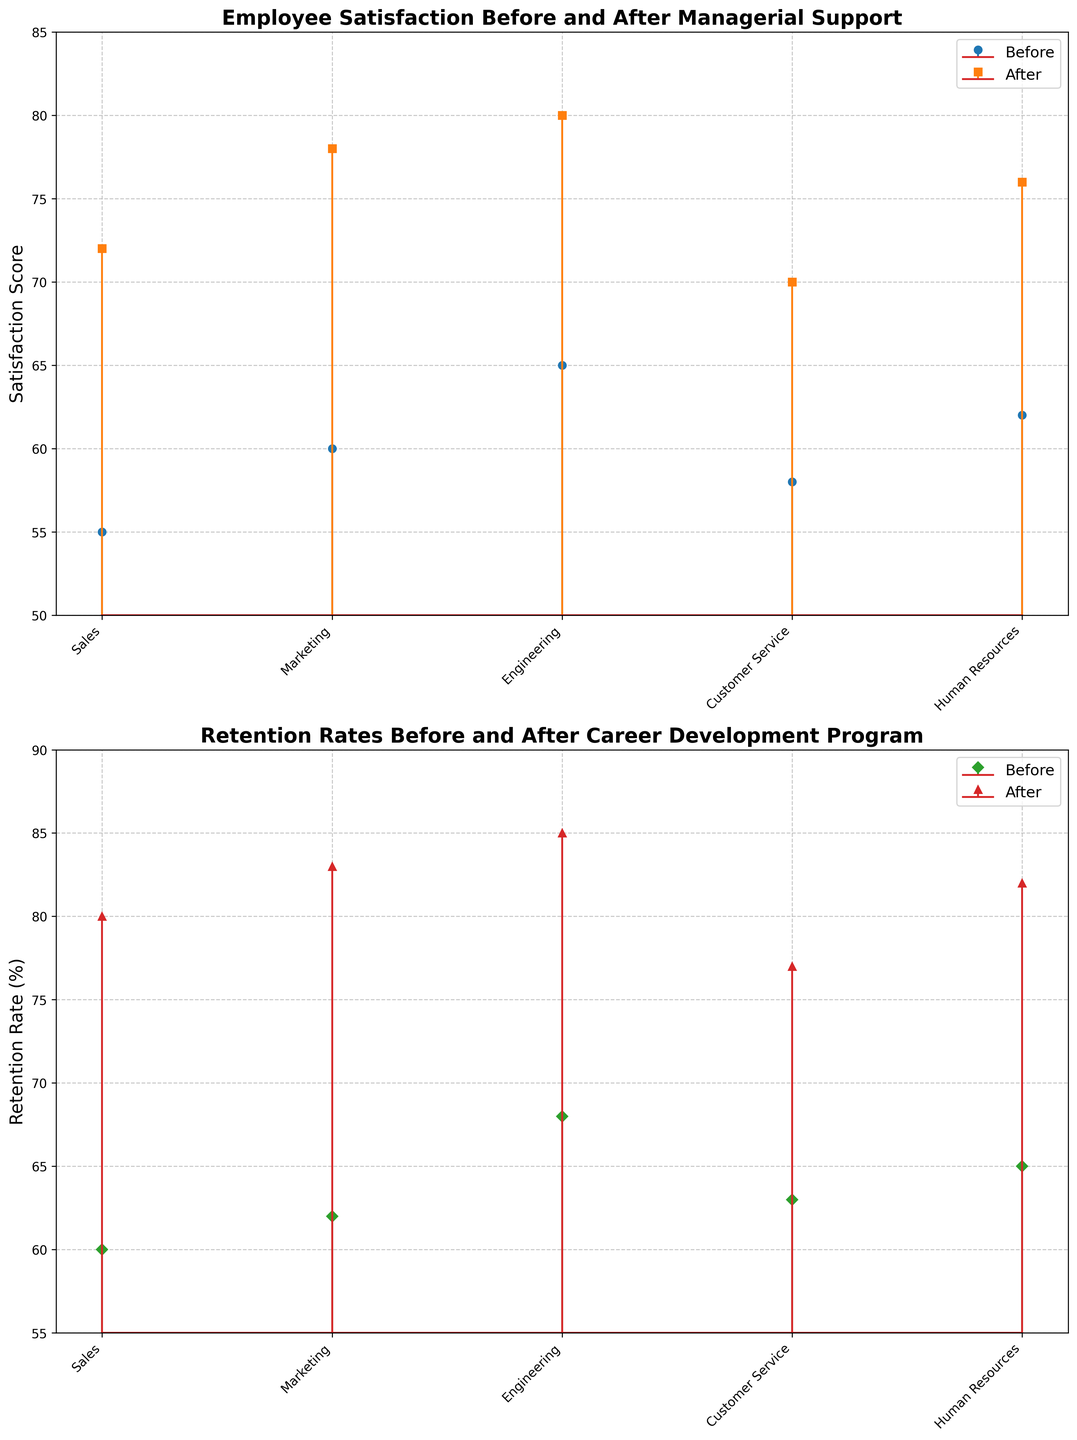Which sector has the highest employee satisfaction score after managerial support? According to the plot, the Engineering sector shows the highest employee satisfaction score after managerial support.
Answer: Engineering What's the difference in customer service employee satisfaction before and after managerial support? The satisfaction score for Customer Service before managerial support is 58, and after it is 70. The difference is 70 - 58.
Answer: 12 Compare the retention rates before and after the career development program for the Sales sector. In the Sales sector, the retention rate before the program is 60, and after it is 80—the increase is 80 - 60.
Answer: 20 Which sector shows the least increase in employee satisfaction after managerial support? The least increase in employee satisfaction is seen in the Customer Service sector, from 58 to 70, which is an increase of 12.
Answer: Customer Service What is the average retention rate after the career development program? The retention rates after the program are 80, 83, 85, 77, and 82. The average is (80 + 83 + 85 + 77 + 82)/5 = 81.4.
Answer: 81.4 Is there any sector where the retention rate after the career development program is less than 80%? Customer Service is the only sector where the retention rate after the program is below 80%, specifically at 77%.
Answer: Customer Service By how many points did the retention rate for Marketing improve after the career development program? The retention rate for Marketing before the program was 62 and improved to 83 afterward. Thus, the increase is 83 - 62.
Answer: 21 Which sector has the smallest retention rate before the career development program, and what is it? The smallest retention rate before the career development program is in Sales, which is at 60%.
Answer: Sales How does Human Resources' satisfaction score change from before to after managerial support? For Human Resources, the satisfaction score increases from 62 to 76, with a change of 76 - 62.
Answer: 14 